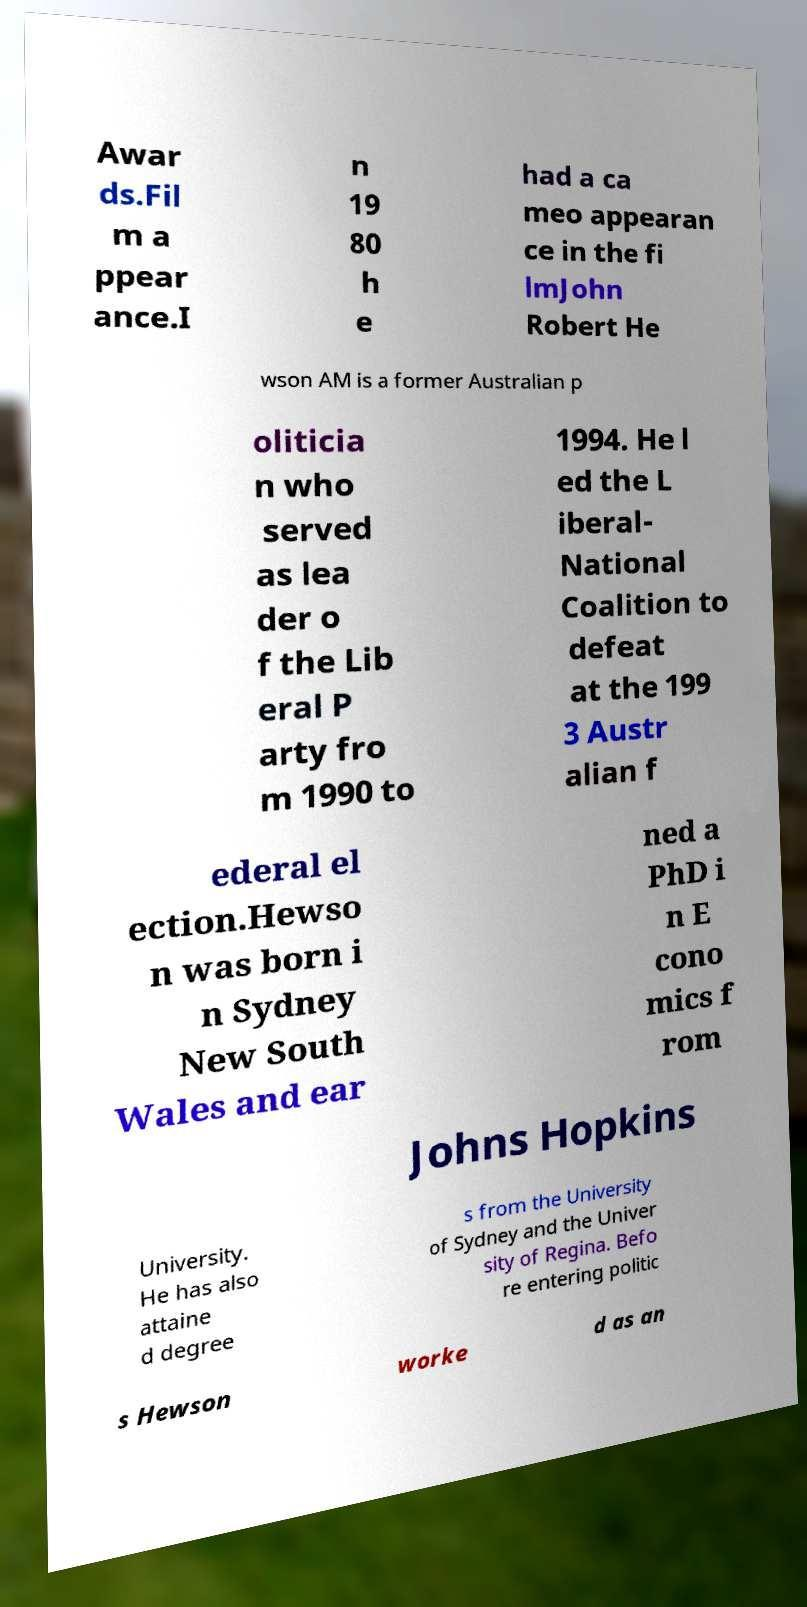Could you extract and type out the text from this image? Awar ds.Fil m a ppear ance.I n 19 80 h e had a ca meo appearan ce in the fi lmJohn Robert He wson AM is a former Australian p oliticia n who served as lea der o f the Lib eral P arty fro m 1990 to 1994. He l ed the L iberal- National Coalition to defeat at the 199 3 Austr alian f ederal el ection.Hewso n was born i n Sydney New South Wales and ear ned a PhD i n E cono mics f rom Johns Hopkins University. He has also attaine d degree s from the University of Sydney and the Univer sity of Regina. Befo re entering politic s Hewson worke d as an 